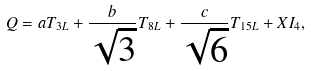Convert formula to latex. <formula><loc_0><loc_0><loc_500><loc_500>Q = a T _ { 3 L } + \frac { b } { \sqrt { 3 } } T _ { 8 L } + \frac { c } { \sqrt { 6 } } T _ { 1 5 L } + X I _ { 4 } ,</formula> 